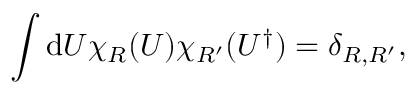Convert formula to latex. <formula><loc_0><loc_0><loc_500><loc_500>\int d U \chi _ { R } ( U ) \chi _ { R ^ { \prime } } ( U ^ { \dagger } ) = \delta _ { R , R ^ { \prime } } ,</formula> 